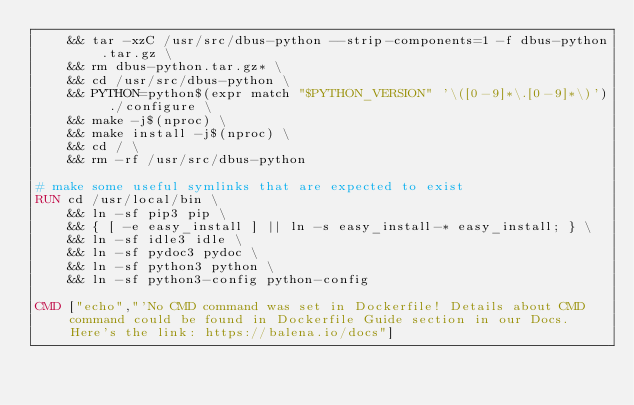Convert code to text. <code><loc_0><loc_0><loc_500><loc_500><_Dockerfile_>	&& tar -xzC /usr/src/dbus-python --strip-components=1 -f dbus-python.tar.gz \
	&& rm dbus-python.tar.gz* \
	&& cd /usr/src/dbus-python \
	&& PYTHON=python$(expr match "$PYTHON_VERSION" '\([0-9]*\.[0-9]*\)') ./configure \
	&& make -j$(nproc) \
	&& make install -j$(nproc) \
	&& cd / \
	&& rm -rf /usr/src/dbus-python

# make some useful symlinks that are expected to exist
RUN cd /usr/local/bin \
	&& ln -sf pip3 pip \
	&& { [ -e easy_install ] || ln -s easy_install-* easy_install; } \
	&& ln -sf idle3 idle \
	&& ln -sf pydoc3 pydoc \
	&& ln -sf python3 python \
	&& ln -sf python3-config python-config

CMD ["echo","'No CMD command was set in Dockerfile! Details about CMD command could be found in Dockerfile Guide section in our Docs. Here's the link: https://balena.io/docs"]</code> 